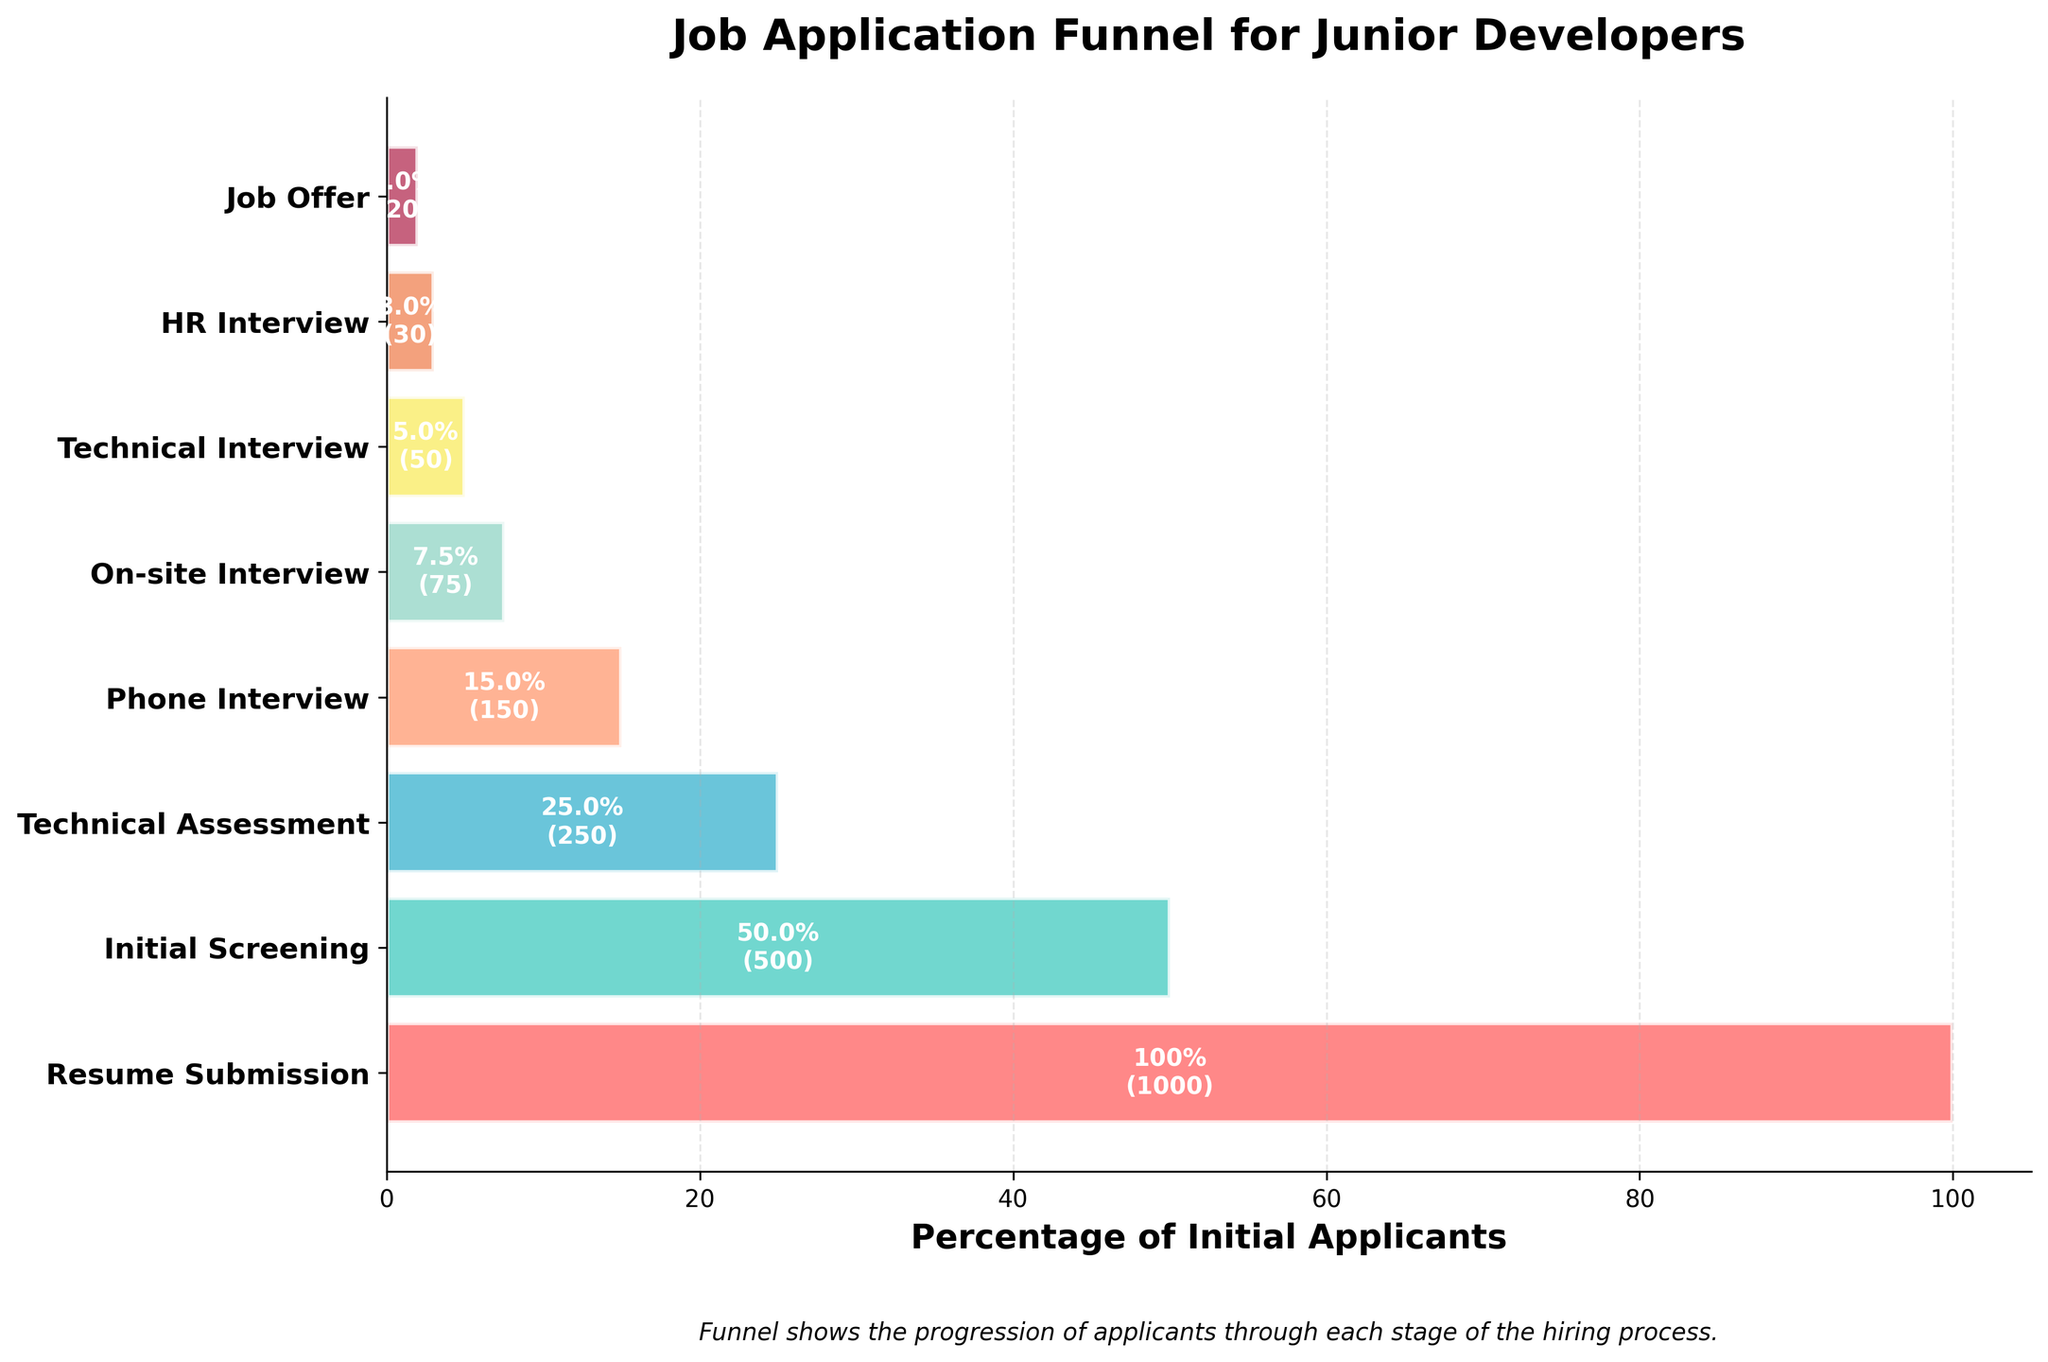What's the total number of stages in the job application funnel? The figure shows the progression of applicants through each stage, which is visually represented by horizontal bars. Each bar corresponds to a unique stage in the funnel. By counting these bars, we can determine the total number of stages.
Answer: 8 What is the title of the figure? The title is typically placed at the top of the figure. It provides a summary of what the chart represents, helping viewers quickly understand the purpose and content of the figure. In this case, it's located above the funnel diagram.
Answer: Job Application Funnel for Junior Developers How many applicants progressed to the Technical Assessment stage? Locate the bar that corresponds to the "Technical Assessment" stage in the funnel chart. The text inside the bar indicates the percentage and the actual number of applicants.
Answer: 250 Which stage has the smallest number of applicants, and how many? By examining the lengths and the annotations of each bar, we can identify the stage with the fewest applicants. This is the shortest bar with the smallest number annotated inside it.
Answer: Job Offer, 20 How many applicants did not progress past the Initial Screening stage? The number of applicants at each stage is provided. To find the number of applicants who did not progress past the Initial Screening, we subtract the number of applicants at the Initial Screening stage from those at the Resume Submission stage. This calculation is 1000 - 500.
Answer: 500 What percentage of the initial applicants made it to the On-site Interview stage? The funnel chart provides percentages for each stage relative to the initial number of applicants. Locate the "On-site Interview" stage and read the percentage value provided inside the corresponding bar.
Answer: 7.5% Compare the number of applicants at the Phone Interview stage versus the HR Interview stage. Which had more applicants and by how many? Locate the bars for both the Phone Interview and HR Interview stages. Read their count values. Subtract the lower value from the higher one to find the difference. Phone Interview has 150 applicants, and HR Interview has 30. The difference is 150 - 30.
Answer: Phone Interview, by 120 What is the difference in the number of applicants between the Technical Interview stage and the Technical Assessment stage? Locate the stages named Technical Interview and Technical Assessment. Note their applicant counts, then subtract the smaller count from the larger count to find the difference. Technical Assessment has 250 applicants, and Technical Interview has 50. The difference is 250 - 50.
Answer: 200 Which stages have fewer than 100 applicants? Review each stage's corresponding bar and the number of applicants it indicates. Identify stages where the annotated number is less than 100.
Answer: On-site Interview, Technical Interview, HR Interview, Job Offer What color represents the Initial Screening stage in the funnel chart? Each stage in the funnel is represented by a different color. The color for Initial Screening corresponds to the specific bar labeled "Initial Screening".
Answer: (custom color corresponding to Initial Screening stage; specify #4ECDC4 in the absence of visual reference) 